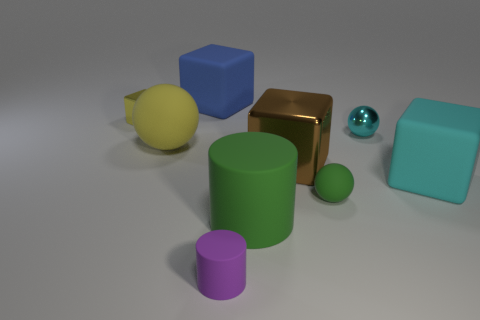Subtract 1 cubes. How many cubes are left? 3 Subtract all blocks. How many objects are left? 5 Add 1 yellow cubes. How many yellow cubes are left? 2 Add 1 small yellow metal cubes. How many small yellow metal cubes exist? 2 Subtract 0 cyan cylinders. How many objects are left? 9 Subtract all tiny green matte objects. Subtract all tiny rubber cylinders. How many objects are left? 7 